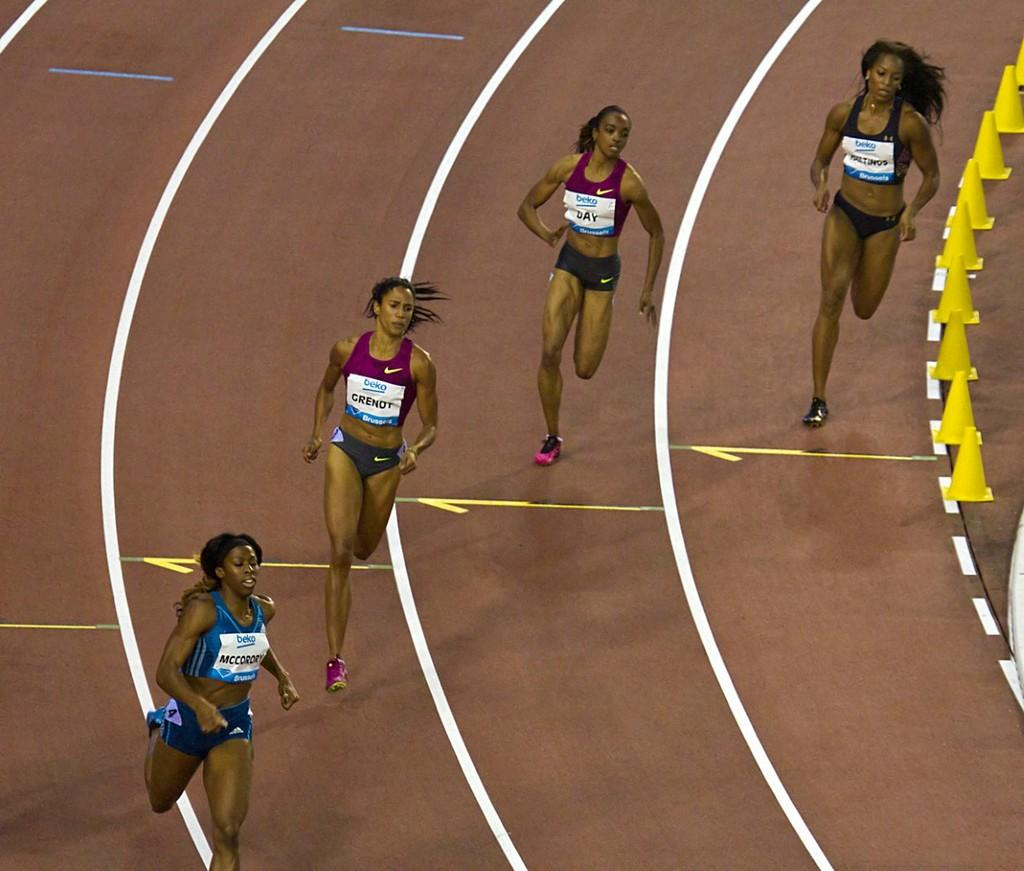Who is present in the image? There are women in the image. What are the women doing in the image? The women are running in the image. Where are the women running in the image? The women are running on a running track in the image. What type of light can be seen coming from the dad in the image? There is no dad present in the image, and therefore no light can be seen coming from him. 